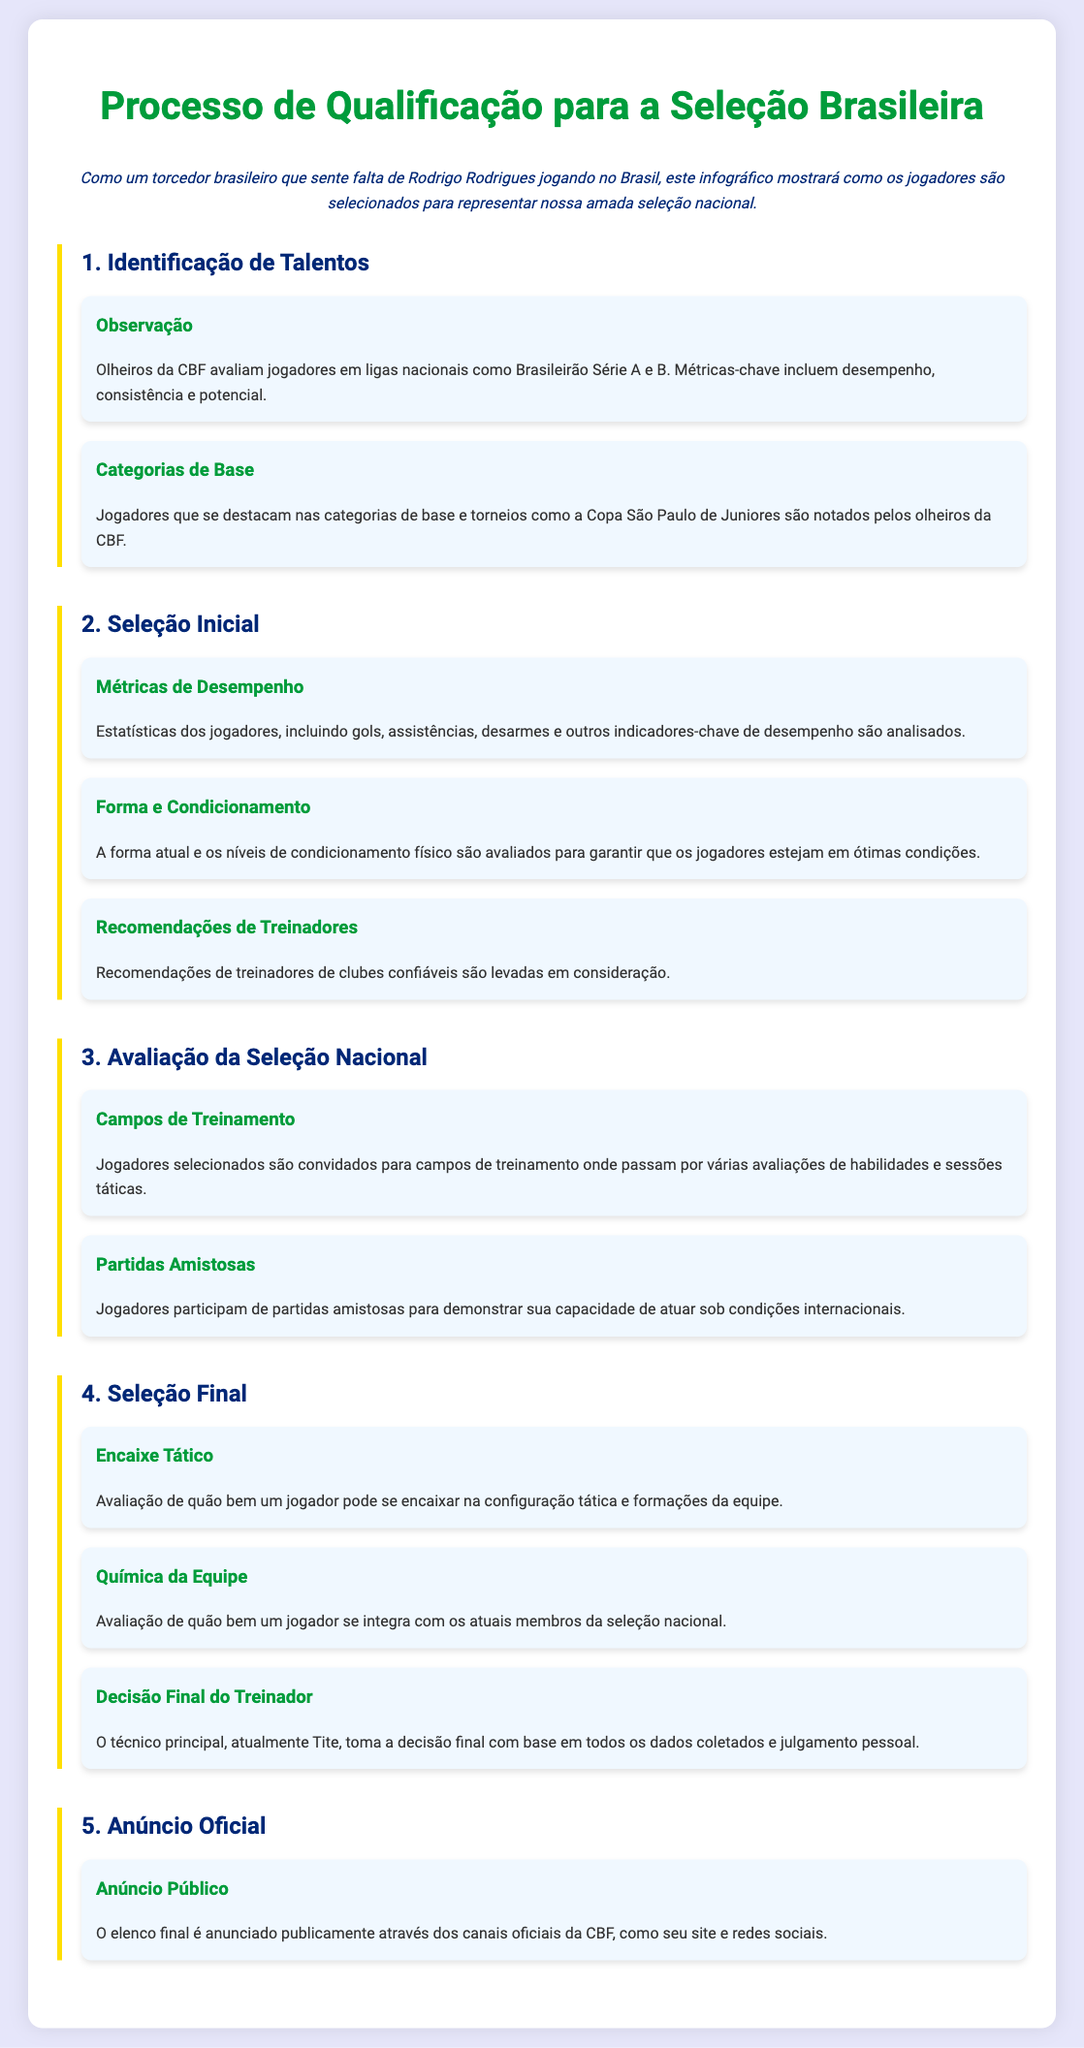Qual é o primeiro estágio do processo de qualificação? O primeiro estágio do processo de qualificação é a "Identificação de Talentos".
Answer: Identificação de Talentos Quais são os dois critérios principais utilizados pelos olheiros da CBF para observar jogadores? Os olheiros da CBF avaliam desempenho e consistência.
Answer: Desempenho e consistência O que é analisado nas "Métricas de Desempenho"? As "Métricas de Desempenho" incluem estatísticas como gols, assistências e desarmes.
Answer: Gols, assistências e desarmes Quem toma a decisão final sobre a seleção de jogadores? A decisão final é tomada pelo técnico principal da seleção.
Answer: Técnico principal Qual é o último estágio do processo? O último estágio do processo é o "Anúncio Oficial".
Answer: Anúncio Oficial Quantos passos são descritos na "Seleção Final"? Na "Seleção Final", são descritos três passos: Encaixe Tático, Química da Equipe, e Decisão Final do Treinador.
Answer: Três passos O que envolve a etapa "Campos de Treinamento"? Na etapa "Campos de Treinamento", jogadores são avaliados em várias habilidades e sessões táticas.
Answer: Avaliações de habilidades e sessões táticas Quais torneios são mencionados para a "Identificação de Talentos"? O infográfico menciona a Copa São Paulo de Juniores como um torneio para a "Identificação de Talentos".
Answer: Copa São Paulo de Juniores 